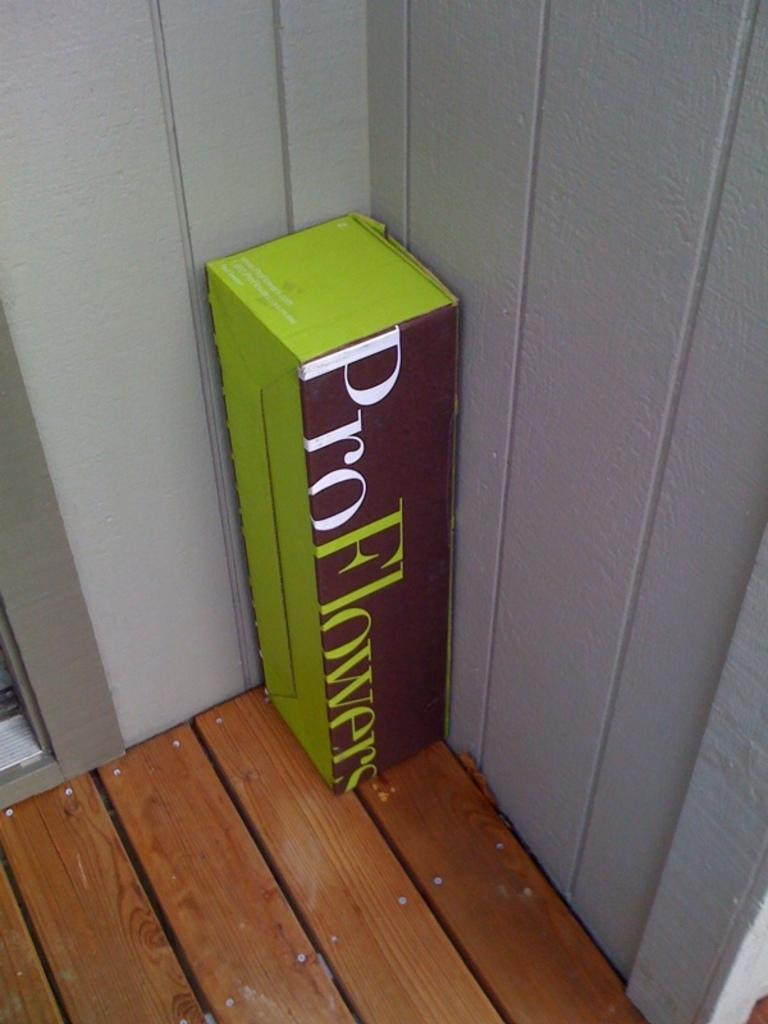Provide a one-sentence caption for the provided image. A box from Pro Flowers sits in the corner of a porch. 